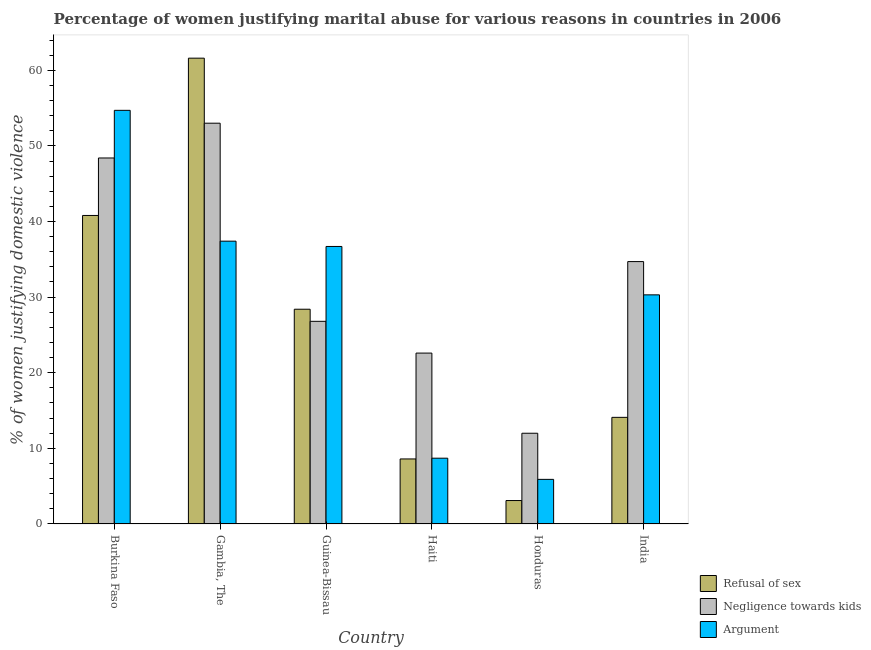How many bars are there on the 3rd tick from the right?
Offer a terse response. 3. What is the label of the 4th group of bars from the left?
Your answer should be very brief. Haiti. In how many cases, is the number of bars for a given country not equal to the number of legend labels?
Give a very brief answer. 0. What is the percentage of women justifying domestic violence due to arguments in Gambia, The?
Make the answer very short. 37.4. Across all countries, what is the maximum percentage of women justifying domestic violence due to arguments?
Offer a very short reply. 54.7. Across all countries, what is the minimum percentage of women justifying domestic violence due to refusal of sex?
Keep it short and to the point. 3.1. In which country was the percentage of women justifying domestic violence due to refusal of sex maximum?
Provide a short and direct response. Gambia, The. In which country was the percentage of women justifying domestic violence due to refusal of sex minimum?
Your response must be concise. Honduras. What is the total percentage of women justifying domestic violence due to arguments in the graph?
Make the answer very short. 173.7. What is the difference between the percentage of women justifying domestic violence due to negligence towards kids in Guinea-Bissau and that in India?
Offer a terse response. -7.9. What is the difference between the percentage of women justifying domestic violence due to arguments in Burkina Faso and the percentage of women justifying domestic violence due to negligence towards kids in Haiti?
Make the answer very short. 32.1. What is the average percentage of women justifying domestic violence due to negligence towards kids per country?
Give a very brief answer. 32.92. In how many countries, is the percentage of women justifying domestic violence due to arguments greater than 56 %?
Keep it short and to the point. 0. What is the ratio of the percentage of women justifying domestic violence due to refusal of sex in Haiti to that in Honduras?
Provide a short and direct response. 2.77. Is the percentage of women justifying domestic violence due to arguments in Burkina Faso less than that in India?
Ensure brevity in your answer.  No. What is the difference between the highest and the second highest percentage of women justifying domestic violence due to negligence towards kids?
Ensure brevity in your answer.  4.6. What is the difference between the highest and the lowest percentage of women justifying domestic violence due to negligence towards kids?
Ensure brevity in your answer.  41. What does the 2nd bar from the left in Burkina Faso represents?
Give a very brief answer. Negligence towards kids. What does the 2nd bar from the right in Honduras represents?
Offer a terse response. Negligence towards kids. Is it the case that in every country, the sum of the percentage of women justifying domestic violence due to refusal of sex and percentage of women justifying domestic violence due to negligence towards kids is greater than the percentage of women justifying domestic violence due to arguments?
Your answer should be compact. Yes. How many bars are there?
Give a very brief answer. 18. Are all the bars in the graph horizontal?
Offer a terse response. No. How many countries are there in the graph?
Keep it short and to the point. 6. Are the values on the major ticks of Y-axis written in scientific E-notation?
Provide a short and direct response. No. Does the graph contain any zero values?
Ensure brevity in your answer.  No. Does the graph contain grids?
Make the answer very short. No. Where does the legend appear in the graph?
Provide a succinct answer. Bottom right. How many legend labels are there?
Your answer should be very brief. 3. What is the title of the graph?
Your response must be concise. Percentage of women justifying marital abuse for various reasons in countries in 2006. What is the label or title of the X-axis?
Give a very brief answer. Country. What is the label or title of the Y-axis?
Make the answer very short. % of women justifying domestic violence. What is the % of women justifying domestic violence in Refusal of sex in Burkina Faso?
Offer a terse response. 40.8. What is the % of women justifying domestic violence in Negligence towards kids in Burkina Faso?
Give a very brief answer. 48.4. What is the % of women justifying domestic violence in Argument in Burkina Faso?
Keep it short and to the point. 54.7. What is the % of women justifying domestic violence of Refusal of sex in Gambia, The?
Offer a very short reply. 61.6. What is the % of women justifying domestic violence in Negligence towards kids in Gambia, The?
Offer a terse response. 53. What is the % of women justifying domestic violence in Argument in Gambia, The?
Your response must be concise. 37.4. What is the % of women justifying domestic violence of Refusal of sex in Guinea-Bissau?
Give a very brief answer. 28.4. What is the % of women justifying domestic violence of Negligence towards kids in Guinea-Bissau?
Give a very brief answer. 26.8. What is the % of women justifying domestic violence in Argument in Guinea-Bissau?
Offer a terse response. 36.7. What is the % of women justifying domestic violence of Refusal of sex in Haiti?
Your response must be concise. 8.6. What is the % of women justifying domestic violence in Negligence towards kids in Haiti?
Ensure brevity in your answer.  22.6. What is the % of women justifying domestic violence in Argument in Haiti?
Your answer should be very brief. 8.7. What is the % of women justifying domestic violence in Refusal of sex in Honduras?
Offer a very short reply. 3.1. What is the % of women justifying domestic violence in Refusal of sex in India?
Your answer should be compact. 14.1. What is the % of women justifying domestic violence in Negligence towards kids in India?
Offer a terse response. 34.7. What is the % of women justifying domestic violence in Argument in India?
Make the answer very short. 30.3. Across all countries, what is the maximum % of women justifying domestic violence in Refusal of sex?
Ensure brevity in your answer.  61.6. Across all countries, what is the maximum % of women justifying domestic violence of Negligence towards kids?
Provide a short and direct response. 53. Across all countries, what is the maximum % of women justifying domestic violence in Argument?
Your answer should be very brief. 54.7. Across all countries, what is the minimum % of women justifying domestic violence of Argument?
Your answer should be very brief. 5.9. What is the total % of women justifying domestic violence of Refusal of sex in the graph?
Your answer should be compact. 156.6. What is the total % of women justifying domestic violence of Negligence towards kids in the graph?
Offer a very short reply. 197.5. What is the total % of women justifying domestic violence in Argument in the graph?
Keep it short and to the point. 173.7. What is the difference between the % of women justifying domestic violence in Refusal of sex in Burkina Faso and that in Gambia, The?
Your response must be concise. -20.8. What is the difference between the % of women justifying domestic violence in Negligence towards kids in Burkina Faso and that in Guinea-Bissau?
Ensure brevity in your answer.  21.6. What is the difference between the % of women justifying domestic violence of Refusal of sex in Burkina Faso and that in Haiti?
Your response must be concise. 32.2. What is the difference between the % of women justifying domestic violence in Negligence towards kids in Burkina Faso and that in Haiti?
Make the answer very short. 25.8. What is the difference between the % of women justifying domestic violence in Argument in Burkina Faso and that in Haiti?
Make the answer very short. 46. What is the difference between the % of women justifying domestic violence in Refusal of sex in Burkina Faso and that in Honduras?
Give a very brief answer. 37.7. What is the difference between the % of women justifying domestic violence in Negligence towards kids in Burkina Faso and that in Honduras?
Your response must be concise. 36.4. What is the difference between the % of women justifying domestic violence of Argument in Burkina Faso and that in Honduras?
Provide a short and direct response. 48.8. What is the difference between the % of women justifying domestic violence of Refusal of sex in Burkina Faso and that in India?
Your answer should be compact. 26.7. What is the difference between the % of women justifying domestic violence of Negligence towards kids in Burkina Faso and that in India?
Offer a terse response. 13.7. What is the difference between the % of women justifying domestic violence of Argument in Burkina Faso and that in India?
Keep it short and to the point. 24.4. What is the difference between the % of women justifying domestic violence of Refusal of sex in Gambia, The and that in Guinea-Bissau?
Provide a short and direct response. 33.2. What is the difference between the % of women justifying domestic violence of Negligence towards kids in Gambia, The and that in Guinea-Bissau?
Your response must be concise. 26.2. What is the difference between the % of women justifying domestic violence in Negligence towards kids in Gambia, The and that in Haiti?
Make the answer very short. 30.4. What is the difference between the % of women justifying domestic violence in Argument in Gambia, The and that in Haiti?
Make the answer very short. 28.7. What is the difference between the % of women justifying domestic violence of Refusal of sex in Gambia, The and that in Honduras?
Provide a succinct answer. 58.5. What is the difference between the % of women justifying domestic violence in Negligence towards kids in Gambia, The and that in Honduras?
Offer a terse response. 41. What is the difference between the % of women justifying domestic violence of Argument in Gambia, The and that in Honduras?
Offer a terse response. 31.5. What is the difference between the % of women justifying domestic violence of Refusal of sex in Gambia, The and that in India?
Offer a terse response. 47.5. What is the difference between the % of women justifying domestic violence of Refusal of sex in Guinea-Bissau and that in Haiti?
Offer a terse response. 19.8. What is the difference between the % of women justifying domestic violence of Negligence towards kids in Guinea-Bissau and that in Haiti?
Offer a very short reply. 4.2. What is the difference between the % of women justifying domestic violence of Argument in Guinea-Bissau and that in Haiti?
Provide a short and direct response. 28. What is the difference between the % of women justifying domestic violence in Refusal of sex in Guinea-Bissau and that in Honduras?
Your response must be concise. 25.3. What is the difference between the % of women justifying domestic violence in Negligence towards kids in Guinea-Bissau and that in Honduras?
Offer a very short reply. 14.8. What is the difference between the % of women justifying domestic violence of Argument in Guinea-Bissau and that in Honduras?
Provide a succinct answer. 30.8. What is the difference between the % of women justifying domestic violence in Negligence towards kids in Guinea-Bissau and that in India?
Your answer should be very brief. -7.9. What is the difference between the % of women justifying domestic violence in Argument in Guinea-Bissau and that in India?
Make the answer very short. 6.4. What is the difference between the % of women justifying domestic violence in Negligence towards kids in Haiti and that in Honduras?
Your answer should be compact. 10.6. What is the difference between the % of women justifying domestic violence of Argument in Haiti and that in Honduras?
Your answer should be very brief. 2.8. What is the difference between the % of women justifying domestic violence of Refusal of sex in Haiti and that in India?
Your answer should be compact. -5.5. What is the difference between the % of women justifying domestic violence in Negligence towards kids in Haiti and that in India?
Ensure brevity in your answer.  -12.1. What is the difference between the % of women justifying domestic violence of Argument in Haiti and that in India?
Give a very brief answer. -21.6. What is the difference between the % of women justifying domestic violence in Refusal of sex in Honduras and that in India?
Your answer should be very brief. -11. What is the difference between the % of women justifying domestic violence of Negligence towards kids in Honduras and that in India?
Keep it short and to the point. -22.7. What is the difference between the % of women justifying domestic violence in Argument in Honduras and that in India?
Provide a short and direct response. -24.4. What is the difference between the % of women justifying domestic violence in Refusal of sex in Burkina Faso and the % of women justifying domestic violence in Argument in Gambia, The?
Provide a succinct answer. 3.4. What is the difference between the % of women justifying domestic violence in Refusal of sex in Burkina Faso and the % of women justifying domestic violence in Negligence towards kids in Guinea-Bissau?
Offer a very short reply. 14. What is the difference between the % of women justifying domestic violence of Negligence towards kids in Burkina Faso and the % of women justifying domestic violence of Argument in Guinea-Bissau?
Keep it short and to the point. 11.7. What is the difference between the % of women justifying domestic violence in Refusal of sex in Burkina Faso and the % of women justifying domestic violence in Negligence towards kids in Haiti?
Your answer should be compact. 18.2. What is the difference between the % of women justifying domestic violence of Refusal of sex in Burkina Faso and the % of women justifying domestic violence of Argument in Haiti?
Your response must be concise. 32.1. What is the difference between the % of women justifying domestic violence of Negligence towards kids in Burkina Faso and the % of women justifying domestic violence of Argument in Haiti?
Offer a very short reply. 39.7. What is the difference between the % of women justifying domestic violence of Refusal of sex in Burkina Faso and the % of women justifying domestic violence of Negligence towards kids in Honduras?
Offer a very short reply. 28.8. What is the difference between the % of women justifying domestic violence in Refusal of sex in Burkina Faso and the % of women justifying domestic violence in Argument in Honduras?
Provide a succinct answer. 34.9. What is the difference between the % of women justifying domestic violence of Negligence towards kids in Burkina Faso and the % of women justifying domestic violence of Argument in Honduras?
Your answer should be very brief. 42.5. What is the difference between the % of women justifying domestic violence of Refusal of sex in Burkina Faso and the % of women justifying domestic violence of Negligence towards kids in India?
Keep it short and to the point. 6.1. What is the difference between the % of women justifying domestic violence of Refusal of sex in Burkina Faso and the % of women justifying domestic violence of Argument in India?
Keep it short and to the point. 10.5. What is the difference between the % of women justifying domestic violence of Refusal of sex in Gambia, The and the % of women justifying domestic violence of Negligence towards kids in Guinea-Bissau?
Make the answer very short. 34.8. What is the difference between the % of women justifying domestic violence in Refusal of sex in Gambia, The and the % of women justifying domestic violence in Argument in Guinea-Bissau?
Your answer should be very brief. 24.9. What is the difference between the % of women justifying domestic violence of Refusal of sex in Gambia, The and the % of women justifying domestic violence of Argument in Haiti?
Give a very brief answer. 52.9. What is the difference between the % of women justifying domestic violence of Negligence towards kids in Gambia, The and the % of women justifying domestic violence of Argument in Haiti?
Give a very brief answer. 44.3. What is the difference between the % of women justifying domestic violence in Refusal of sex in Gambia, The and the % of women justifying domestic violence in Negligence towards kids in Honduras?
Your answer should be compact. 49.6. What is the difference between the % of women justifying domestic violence of Refusal of sex in Gambia, The and the % of women justifying domestic violence of Argument in Honduras?
Your answer should be compact. 55.7. What is the difference between the % of women justifying domestic violence of Negligence towards kids in Gambia, The and the % of women justifying domestic violence of Argument in Honduras?
Provide a short and direct response. 47.1. What is the difference between the % of women justifying domestic violence in Refusal of sex in Gambia, The and the % of women justifying domestic violence in Negligence towards kids in India?
Your response must be concise. 26.9. What is the difference between the % of women justifying domestic violence in Refusal of sex in Gambia, The and the % of women justifying domestic violence in Argument in India?
Keep it short and to the point. 31.3. What is the difference between the % of women justifying domestic violence in Negligence towards kids in Gambia, The and the % of women justifying domestic violence in Argument in India?
Give a very brief answer. 22.7. What is the difference between the % of women justifying domestic violence in Refusal of sex in Guinea-Bissau and the % of women justifying domestic violence in Negligence towards kids in Haiti?
Make the answer very short. 5.8. What is the difference between the % of women justifying domestic violence of Refusal of sex in Guinea-Bissau and the % of women justifying domestic violence of Argument in Haiti?
Offer a terse response. 19.7. What is the difference between the % of women justifying domestic violence of Refusal of sex in Guinea-Bissau and the % of women justifying domestic violence of Negligence towards kids in Honduras?
Offer a very short reply. 16.4. What is the difference between the % of women justifying domestic violence of Refusal of sex in Guinea-Bissau and the % of women justifying domestic violence of Argument in Honduras?
Give a very brief answer. 22.5. What is the difference between the % of women justifying domestic violence of Negligence towards kids in Guinea-Bissau and the % of women justifying domestic violence of Argument in Honduras?
Your response must be concise. 20.9. What is the difference between the % of women justifying domestic violence of Refusal of sex in Haiti and the % of women justifying domestic violence of Negligence towards kids in Honduras?
Your response must be concise. -3.4. What is the difference between the % of women justifying domestic violence of Negligence towards kids in Haiti and the % of women justifying domestic violence of Argument in Honduras?
Your answer should be compact. 16.7. What is the difference between the % of women justifying domestic violence in Refusal of sex in Haiti and the % of women justifying domestic violence in Negligence towards kids in India?
Your response must be concise. -26.1. What is the difference between the % of women justifying domestic violence in Refusal of sex in Haiti and the % of women justifying domestic violence in Argument in India?
Make the answer very short. -21.7. What is the difference between the % of women justifying domestic violence of Negligence towards kids in Haiti and the % of women justifying domestic violence of Argument in India?
Keep it short and to the point. -7.7. What is the difference between the % of women justifying domestic violence in Refusal of sex in Honduras and the % of women justifying domestic violence in Negligence towards kids in India?
Your answer should be very brief. -31.6. What is the difference between the % of women justifying domestic violence in Refusal of sex in Honduras and the % of women justifying domestic violence in Argument in India?
Provide a short and direct response. -27.2. What is the difference between the % of women justifying domestic violence of Negligence towards kids in Honduras and the % of women justifying domestic violence of Argument in India?
Your answer should be compact. -18.3. What is the average % of women justifying domestic violence of Refusal of sex per country?
Provide a succinct answer. 26.1. What is the average % of women justifying domestic violence in Negligence towards kids per country?
Make the answer very short. 32.92. What is the average % of women justifying domestic violence in Argument per country?
Your response must be concise. 28.95. What is the difference between the % of women justifying domestic violence of Refusal of sex and % of women justifying domestic violence of Argument in Gambia, The?
Ensure brevity in your answer.  24.2. What is the difference between the % of women justifying domestic violence of Negligence towards kids and % of women justifying domestic violence of Argument in Gambia, The?
Make the answer very short. 15.6. What is the difference between the % of women justifying domestic violence in Refusal of sex and % of women justifying domestic violence in Negligence towards kids in Guinea-Bissau?
Offer a very short reply. 1.6. What is the difference between the % of women justifying domestic violence of Refusal of sex and % of women justifying domestic violence of Argument in Guinea-Bissau?
Offer a very short reply. -8.3. What is the difference between the % of women justifying domestic violence of Negligence towards kids and % of women justifying domestic violence of Argument in Guinea-Bissau?
Offer a terse response. -9.9. What is the difference between the % of women justifying domestic violence in Refusal of sex and % of women justifying domestic violence in Argument in Haiti?
Your answer should be compact. -0.1. What is the difference between the % of women justifying domestic violence of Refusal of sex and % of women justifying domestic violence of Negligence towards kids in India?
Give a very brief answer. -20.6. What is the difference between the % of women justifying domestic violence of Refusal of sex and % of women justifying domestic violence of Argument in India?
Offer a terse response. -16.2. What is the ratio of the % of women justifying domestic violence in Refusal of sex in Burkina Faso to that in Gambia, The?
Provide a succinct answer. 0.66. What is the ratio of the % of women justifying domestic violence in Negligence towards kids in Burkina Faso to that in Gambia, The?
Give a very brief answer. 0.91. What is the ratio of the % of women justifying domestic violence of Argument in Burkina Faso to that in Gambia, The?
Provide a succinct answer. 1.46. What is the ratio of the % of women justifying domestic violence of Refusal of sex in Burkina Faso to that in Guinea-Bissau?
Provide a short and direct response. 1.44. What is the ratio of the % of women justifying domestic violence of Negligence towards kids in Burkina Faso to that in Guinea-Bissau?
Your answer should be compact. 1.81. What is the ratio of the % of women justifying domestic violence in Argument in Burkina Faso to that in Guinea-Bissau?
Keep it short and to the point. 1.49. What is the ratio of the % of women justifying domestic violence in Refusal of sex in Burkina Faso to that in Haiti?
Offer a terse response. 4.74. What is the ratio of the % of women justifying domestic violence in Negligence towards kids in Burkina Faso to that in Haiti?
Make the answer very short. 2.14. What is the ratio of the % of women justifying domestic violence of Argument in Burkina Faso to that in Haiti?
Make the answer very short. 6.29. What is the ratio of the % of women justifying domestic violence of Refusal of sex in Burkina Faso to that in Honduras?
Make the answer very short. 13.16. What is the ratio of the % of women justifying domestic violence in Negligence towards kids in Burkina Faso to that in Honduras?
Ensure brevity in your answer.  4.03. What is the ratio of the % of women justifying domestic violence of Argument in Burkina Faso to that in Honduras?
Your response must be concise. 9.27. What is the ratio of the % of women justifying domestic violence in Refusal of sex in Burkina Faso to that in India?
Offer a very short reply. 2.89. What is the ratio of the % of women justifying domestic violence of Negligence towards kids in Burkina Faso to that in India?
Offer a terse response. 1.39. What is the ratio of the % of women justifying domestic violence of Argument in Burkina Faso to that in India?
Provide a short and direct response. 1.81. What is the ratio of the % of women justifying domestic violence of Refusal of sex in Gambia, The to that in Guinea-Bissau?
Your answer should be compact. 2.17. What is the ratio of the % of women justifying domestic violence of Negligence towards kids in Gambia, The to that in Guinea-Bissau?
Make the answer very short. 1.98. What is the ratio of the % of women justifying domestic violence of Argument in Gambia, The to that in Guinea-Bissau?
Provide a succinct answer. 1.02. What is the ratio of the % of women justifying domestic violence in Refusal of sex in Gambia, The to that in Haiti?
Keep it short and to the point. 7.16. What is the ratio of the % of women justifying domestic violence in Negligence towards kids in Gambia, The to that in Haiti?
Ensure brevity in your answer.  2.35. What is the ratio of the % of women justifying domestic violence of Argument in Gambia, The to that in Haiti?
Your answer should be very brief. 4.3. What is the ratio of the % of women justifying domestic violence of Refusal of sex in Gambia, The to that in Honduras?
Your response must be concise. 19.87. What is the ratio of the % of women justifying domestic violence of Negligence towards kids in Gambia, The to that in Honduras?
Your response must be concise. 4.42. What is the ratio of the % of women justifying domestic violence of Argument in Gambia, The to that in Honduras?
Offer a terse response. 6.34. What is the ratio of the % of women justifying domestic violence in Refusal of sex in Gambia, The to that in India?
Offer a terse response. 4.37. What is the ratio of the % of women justifying domestic violence in Negligence towards kids in Gambia, The to that in India?
Your response must be concise. 1.53. What is the ratio of the % of women justifying domestic violence of Argument in Gambia, The to that in India?
Give a very brief answer. 1.23. What is the ratio of the % of women justifying domestic violence in Refusal of sex in Guinea-Bissau to that in Haiti?
Make the answer very short. 3.3. What is the ratio of the % of women justifying domestic violence of Negligence towards kids in Guinea-Bissau to that in Haiti?
Offer a terse response. 1.19. What is the ratio of the % of women justifying domestic violence in Argument in Guinea-Bissau to that in Haiti?
Give a very brief answer. 4.22. What is the ratio of the % of women justifying domestic violence of Refusal of sex in Guinea-Bissau to that in Honduras?
Offer a terse response. 9.16. What is the ratio of the % of women justifying domestic violence of Negligence towards kids in Guinea-Bissau to that in Honduras?
Offer a very short reply. 2.23. What is the ratio of the % of women justifying domestic violence in Argument in Guinea-Bissau to that in Honduras?
Offer a very short reply. 6.22. What is the ratio of the % of women justifying domestic violence of Refusal of sex in Guinea-Bissau to that in India?
Keep it short and to the point. 2.01. What is the ratio of the % of women justifying domestic violence of Negligence towards kids in Guinea-Bissau to that in India?
Keep it short and to the point. 0.77. What is the ratio of the % of women justifying domestic violence of Argument in Guinea-Bissau to that in India?
Give a very brief answer. 1.21. What is the ratio of the % of women justifying domestic violence in Refusal of sex in Haiti to that in Honduras?
Give a very brief answer. 2.77. What is the ratio of the % of women justifying domestic violence in Negligence towards kids in Haiti to that in Honduras?
Provide a short and direct response. 1.88. What is the ratio of the % of women justifying domestic violence of Argument in Haiti to that in Honduras?
Your response must be concise. 1.47. What is the ratio of the % of women justifying domestic violence in Refusal of sex in Haiti to that in India?
Your answer should be compact. 0.61. What is the ratio of the % of women justifying domestic violence in Negligence towards kids in Haiti to that in India?
Provide a succinct answer. 0.65. What is the ratio of the % of women justifying domestic violence of Argument in Haiti to that in India?
Provide a short and direct response. 0.29. What is the ratio of the % of women justifying domestic violence of Refusal of sex in Honduras to that in India?
Ensure brevity in your answer.  0.22. What is the ratio of the % of women justifying domestic violence of Negligence towards kids in Honduras to that in India?
Provide a succinct answer. 0.35. What is the ratio of the % of women justifying domestic violence of Argument in Honduras to that in India?
Your answer should be very brief. 0.19. What is the difference between the highest and the second highest % of women justifying domestic violence in Refusal of sex?
Give a very brief answer. 20.8. What is the difference between the highest and the second highest % of women justifying domestic violence in Argument?
Your response must be concise. 17.3. What is the difference between the highest and the lowest % of women justifying domestic violence of Refusal of sex?
Make the answer very short. 58.5. What is the difference between the highest and the lowest % of women justifying domestic violence of Argument?
Offer a terse response. 48.8. 